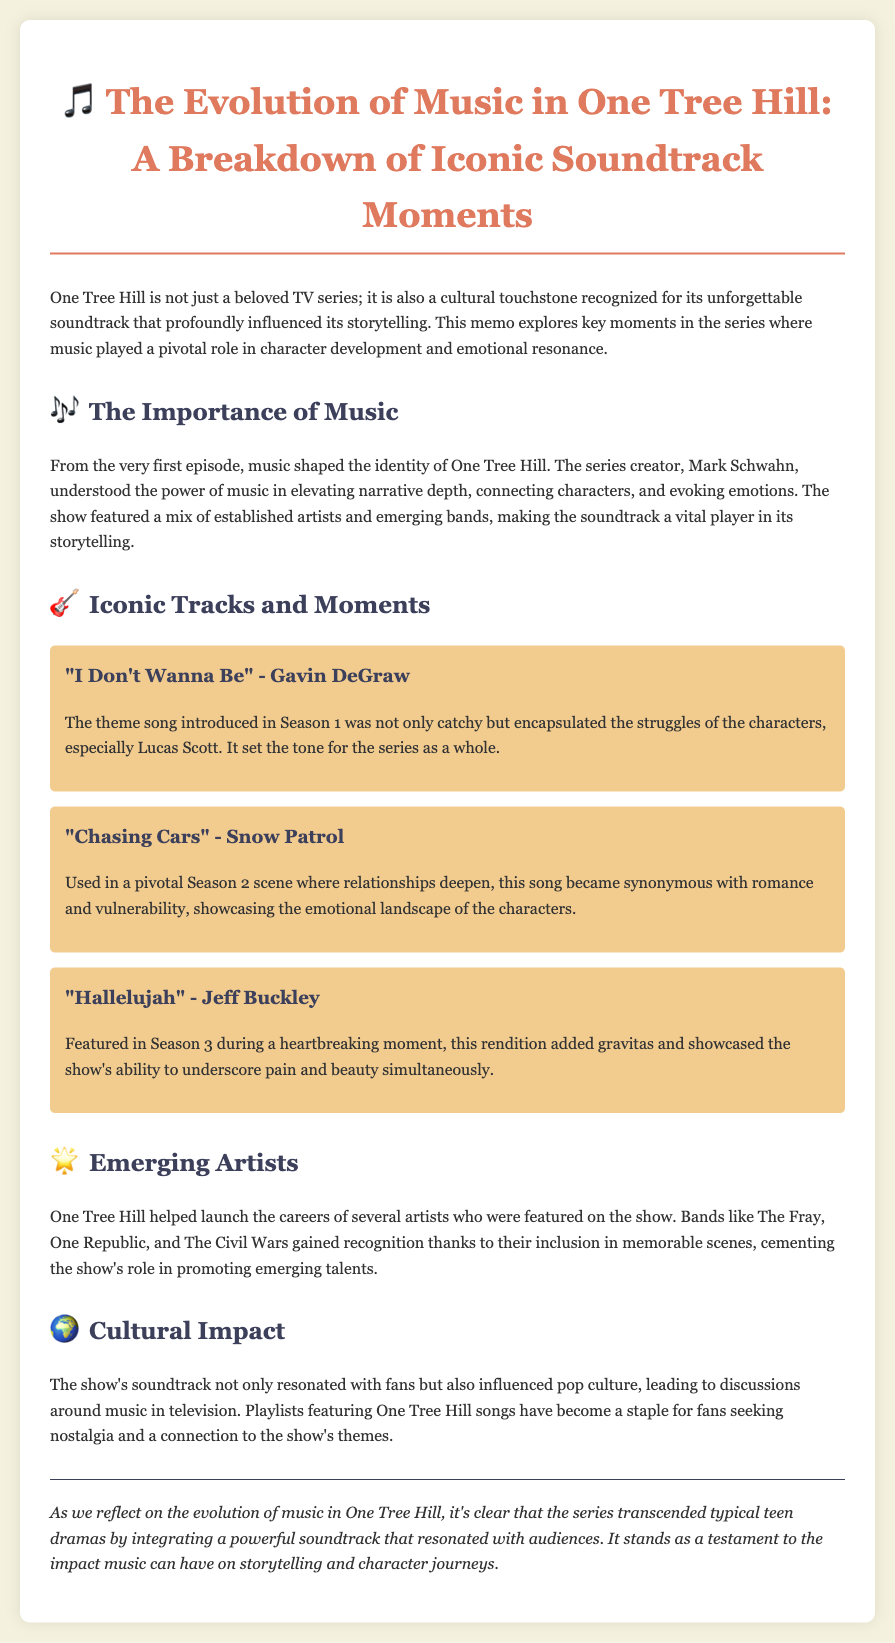What is the title of the document? The title is specified in the header of the document, which is "The Evolution of Music in One Tree Hill: A Breakdown of Iconic Soundtrack Moments."
Answer: The Evolution of Music in One Tree Hill: A Breakdown of Iconic Soundtrack Moments Who performed the theme song for One Tree Hill? The theme song is attributed to the artist Gavin DeGraw, mentioned in the section about iconic tracks.
Answer: Gavin DeGraw In which season is "Chasing Cars" by Snow Patrol featured? The document states that "Chasing Cars" is used in a pivotal scene during Season 2.
Answer: Season 2 Which band gained recognition through their appearance on the show? The document lists several bands that gained recognition; one example is The Fray.
Answer: The Fray What type of impact did the show's soundtrack have on pop culture? The document highlights that the soundtrack influenced discussions about music in television and created nostalgia among fans.
Answer: Influenced discussions about music in television Why is the music considered vital in One Tree Hill? The document explains that music shaped the identity of One Tree Hill and elevated narrative depth connecting characters.
Answer: Elevated narrative depth What song featured during a heartbreaking moment in Season 3? The document specifies that "Hallelujah" by Jeff Buckley was featured during a heartbreaking moment.
Answer: Hallelujah What is the conclusion of the memo about the show's soundtrack? The conclusion summarizes that the series transcended typical teen dramas through its powerful soundtrack and its impact on storytelling.
Answer: Impact on storytelling 